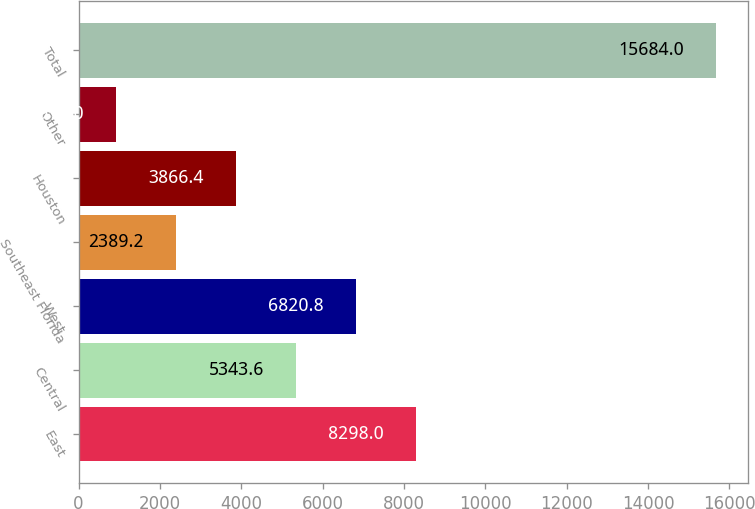<chart> <loc_0><loc_0><loc_500><loc_500><bar_chart><fcel>East<fcel>Central<fcel>West<fcel>Southeast Florida<fcel>Houston<fcel>Other<fcel>Total<nl><fcel>8298<fcel>5343.6<fcel>6820.8<fcel>2389.2<fcel>3866.4<fcel>912<fcel>15684<nl></chart> 